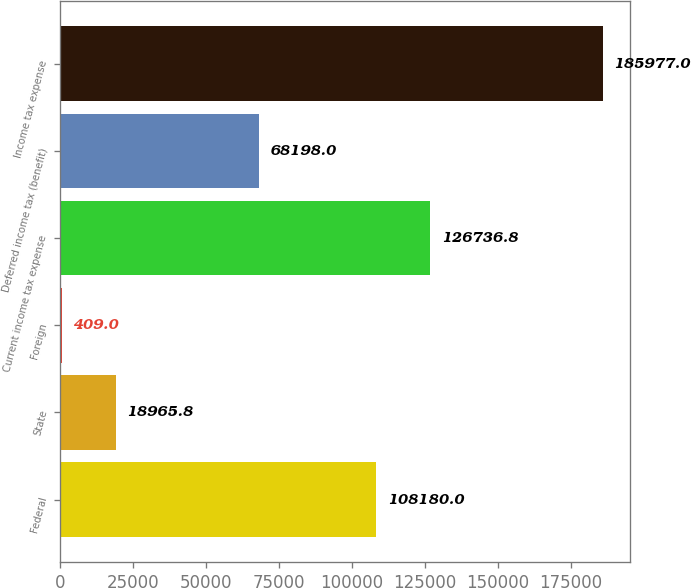<chart> <loc_0><loc_0><loc_500><loc_500><bar_chart><fcel>Federal<fcel>State<fcel>Foreign<fcel>Current income tax expense<fcel>Deferred income tax (benefit)<fcel>Income tax expense<nl><fcel>108180<fcel>18965.8<fcel>409<fcel>126737<fcel>68198<fcel>185977<nl></chart> 